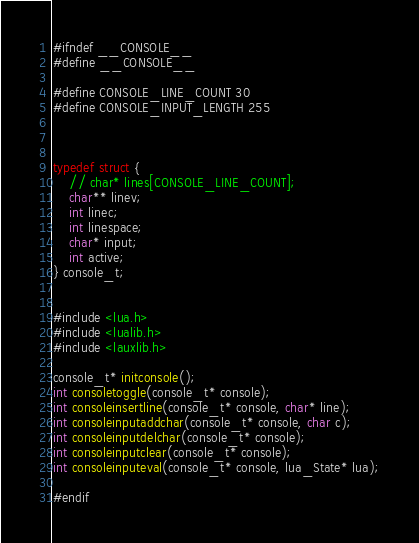<code> <loc_0><loc_0><loc_500><loc_500><_C_>#ifndef __CONSOLE__
#define __CONSOLE__

#define CONSOLE_LINE_COUNT 30
#define CONSOLE_INPUT_LENGTH 255



typedef struct {
	// char* lines[CONSOLE_LINE_COUNT];
	char** linev;
	int linec;
	int linespace;
	char* input;
	int active;
} console_t;


#include <lua.h>
#include <lualib.h>
#include <lauxlib.h>

console_t* initconsole();
int consoletoggle(console_t* console);
int consoleinsertline(console_t* console, char* line);
int consoleinputaddchar(console_t* console, char c);
int consoleinputdelchar(console_t* console);
int consoleinputclear(console_t* console);
int consoleinputeval(console_t* console, lua_State* lua);

#endif</code> 